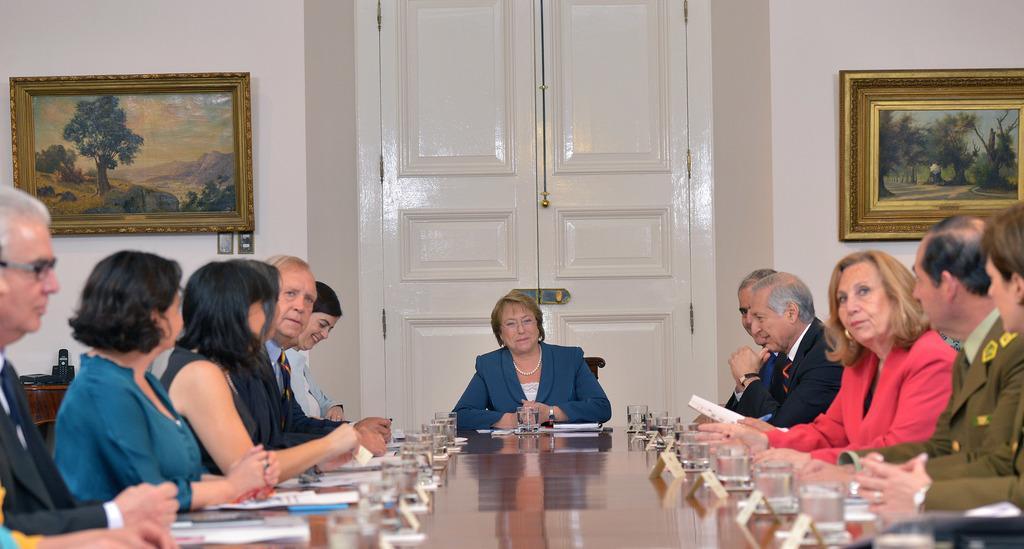In one or two sentences, can you explain what this image depicts? There are group of people sitting on the either side of the table and there a women wearing blue suit sitting in middle of them and there is a white door back of her. 